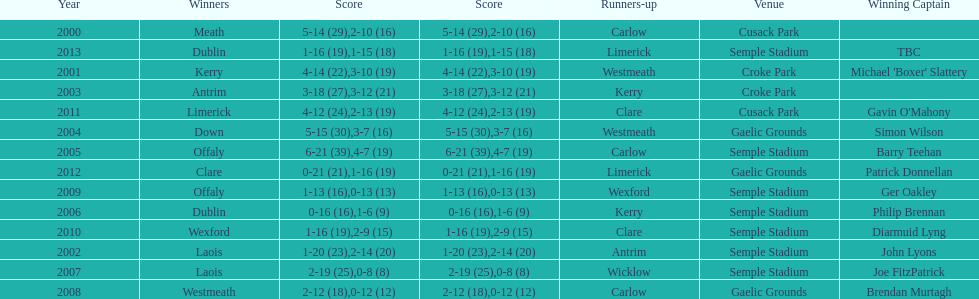Who was the winning captain the last time the competition was held at the gaelic grounds venue? Patrick Donnellan. 